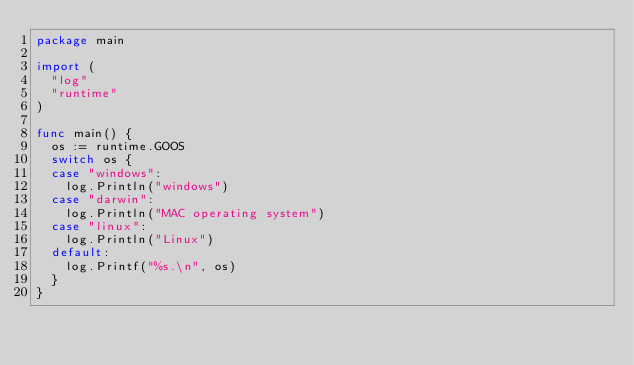Convert code to text. <code><loc_0><loc_0><loc_500><loc_500><_Go_>package main

import (
	"log"
	"runtime"
)

func main() {
	os := runtime.GOOS
	switch os {
	case "windows":
		log.Println("windows")
	case "darwin":
		log.Println("MAC operating system")
	case "linux":
		log.Println("Linux")
	default:
		log.Printf("%s.\n", os)
	}
}
</code> 